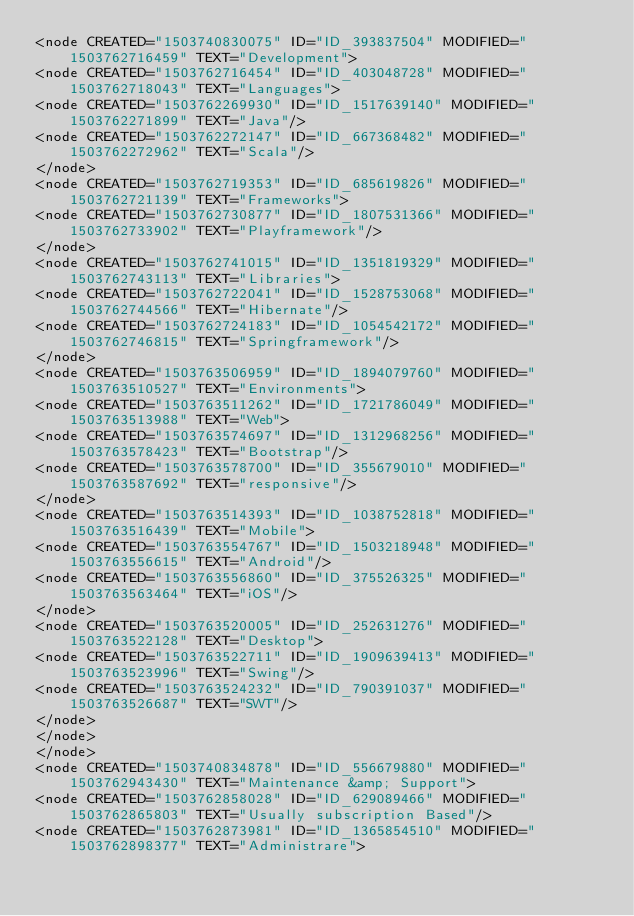<code> <loc_0><loc_0><loc_500><loc_500><_ObjectiveC_><node CREATED="1503740830075" ID="ID_393837504" MODIFIED="1503762716459" TEXT="Development">
<node CREATED="1503762716454" ID="ID_403048728" MODIFIED="1503762718043" TEXT="Languages">
<node CREATED="1503762269930" ID="ID_1517639140" MODIFIED="1503762271899" TEXT="Java"/>
<node CREATED="1503762272147" ID="ID_667368482" MODIFIED="1503762272962" TEXT="Scala"/>
</node>
<node CREATED="1503762719353" ID="ID_685619826" MODIFIED="1503762721139" TEXT="Frameworks">
<node CREATED="1503762730877" ID="ID_1807531366" MODIFIED="1503762733902" TEXT="Playframework"/>
</node>
<node CREATED="1503762741015" ID="ID_1351819329" MODIFIED="1503762743113" TEXT="Libraries">
<node CREATED="1503762722041" ID="ID_1528753068" MODIFIED="1503762744566" TEXT="Hibernate"/>
<node CREATED="1503762724183" ID="ID_1054542172" MODIFIED="1503762746815" TEXT="Springframework"/>
</node>
<node CREATED="1503763506959" ID="ID_1894079760" MODIFIED="1503763510527" TEXT="Environments">
<node CREATED="1503763511262" ID="ID_1721786049" MODIFIED="1503763513988" TEXT="Web">
<node CREATED="1503763574697" ID="ID_1312968256" MODIFIED="1503763578423" TEXT="Bootstrap"/>
<node CREATED="1503763578700" ID="ID_355679010" MODIFIED="1503763587692" TEXT="responsive"/>
</node>
<node CREATED="1503763514393" ID="ID_1038752818" MODIFIED="1503763516439" TEXT="Mobile">
<node CREATED="1503763554767" ID="ID_1503218948" MODIFIED="1503763556615" TEXT="Android"/>
<node CREATED="1503763556860" ID="ID_375526325" MODIFIED="1503763563464" TEXT="iOS"/>
</node>
<node CREATED="1503763520005" ID="ID_252631276" MODIFIED="1503763522128" TEXT="Desktop">
<node CREATED="1503763522711" ID="ID_1909639413" MODIFIED="1503763523996" TEXT="Swing"/>
<node CREATED="1503763524232" ID="ID_790391037" MODIFIED="1503763526687" TEXT="SWT"/>
</node>
</node>
</node>
<node CREATED="1503740834878" ID="ID_556679880" MODIFIED="1503762943430" TEXT="Maintenance &amp; Support">
<node CREATED="1503762858028" ID="ID_629089466" MODIFIED="1503762865803" TEXT="Usually subscription Based"/>
<node CREATED="1503762873981" ID="ID_1365854510" MODIFIED="1503762898377" TEXT="Administrare"></code> 